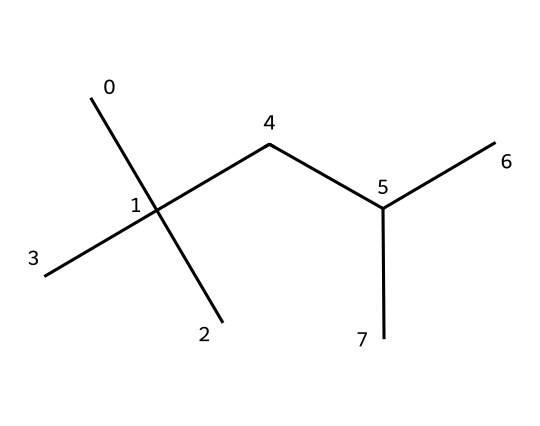What is the name of the compound represented by this structure? The structure represented by the provided SMILES corresponds to isooctane, a branched-chain alkane commonly found in gasoline.
Answer: isooctane How many carbon atoms are present in isooctane? By analyzing the SMILES structure, we see that there are 8 carbon atoms (C) branching in the compound.
Answer: 8 What type of hydrocarbon is isooctane classified as? Isooctane is classified as an aliphatic hydrocarbon due to its open-chain structure containing single bonds between carbon atoms.
Answer: aliphatic What is the degree of branching in isooctane? The structure shows multiple branch points where carbon atoms extend from the main chain, indicating it has a high degree of branching.
Answer: high What is the molecular formula of isooctane? By counting the carbon (C) and hydrogen (H) atoms in the compound, the molecular formula can be derived as C8H18.
Answer: C8H18 How many hydrogen atoms are bonded to the carbon atoms in isooctane? Each carbon can bond to hydrogen atoms in a way that fulfills its tetravalency; when calculated, we find there are 18 hydrogen atoms (H) bonded to the 8 carbon atoms.
Answer: 18 What is the relationship between isooctane and its octane rating? Isooctane is used as a standard reference point for determining the octane rating of fuels, representing a high-performance gasoline component.
Answer: reference point 